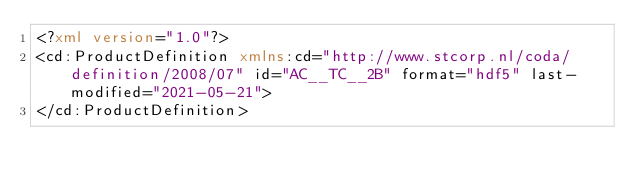<code> <loc_0><loc_0><loc_500><loc_500><_XML_><?xml version="1.0"?>
<cd:ProductDefinition xmlns:cd="http://www.stcorp.nl/coda/definition/2008/07" id="AC__TC__2B" format="hdf5" last-modified="2021-05-21">
</cd:ProductDefinition>
</code> 